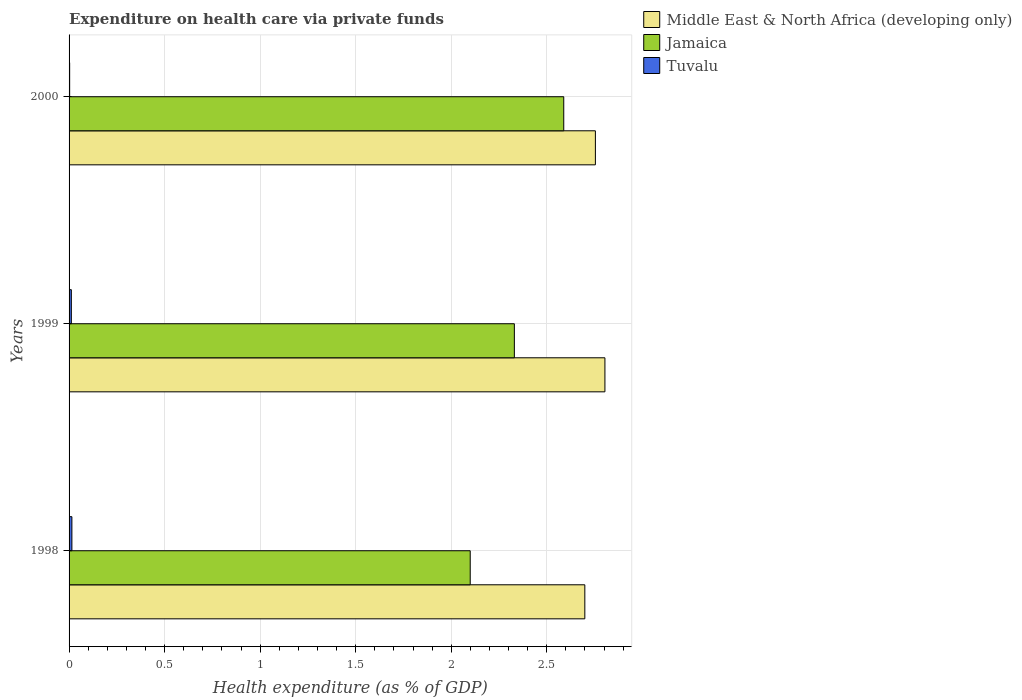Are the number of bars on each tick of the Y-axis equal?
Keep it short and to the point. Yes. How many bars are there on the 2nd tick from the top?
Ensure brevity in your answer.  3. How many bars are there on the 1st tick from the bottom?
Provide a succinct answer. 3. What is the label of the 1st group of bars from the top?
Offer a very short reply. 2000. What is the expenditure made on health care in Tuvalu in 1999?
Give a very brief answer. 0.01. Across all years, what is the maximum expenditure made on health care in Tuvalu?
Provide a succinct answer. 0.01. Across all years, what is the minimum expenditure made on health care in Jamaica?
Provide a short and direct response. 2.1. In which year was the expenditure made on health care in Jamaica minimum?
Ensure brevity in your answer.  1998. What is the total expenditure made on health care in Middle East & North Africa (developing only) in the graph?
Your answer should be compact. 8.26. What is the difference between the expenditure made on health care in Tuvalu in 1998 and that in 2000?
Provide a short and direct response. 0.01. What is the difference between the expenditure made on health care in Middle East & North Africa (developing only) in 2000 and the expenditure made on health care in Jamaica in 1998?
Your response must be concise. 0.66. What is the average expenditure made on health care in Tuvalu per year?
Make the answer very short. 0.01. In the year 1998, what is the difference between the expenditure made on health care in Tuvalu and expenditure made on health care in Jamaica?
Keep it short and to the point. -2.08. What is the ratio of the expenditure made on health care in Middle East & North Africa (developing only) in 1999 to that in 2000?
Provide a short and direct response. 1.02. What is the difference between the highest and the second highest expenditure made on health care in Middle East & North Africa (developing only)?
Your answer should be compact. 0.05. What is the difference between the highest and the lowest expenditure made on health care in Middle East & North Africa (developing only)?
Provide a succinct answer. 0.11. What does the 1st bar from the top in 1999 represents?
Give a very brief answer. Tuvalu. What does the 3rd bar from the bottom in 1999 represents?
Keep it short and to the point. Tuvalu. Is it the case that in every year, the sum of the expenditure made on health care in Tuvalu and expenditure made on health care in Jamaica is greater than the expenditure made on health care in Middle East & North Africa (developing only)?
Make the answer very short. No. How many years are there in the graph?
Provide a succinct answer. 3. What is the difference between two consecutive major ticks on the X-axis?
Provide a short and direct response. 0.5. Are the values on the major ticks of X-axis written in scientific E-notation?
Offer a terse response. No. What is the title of the graph?
Give a very brief answer. Expenditure on health care via private funds. Does "Mauritania" appear as one of the legend labels in the graph?
Make the answer very short. No. What is the label or title of the X-axis?
Give a very brief answer. Health expenditure (as % of GDP). What is the Health expenditure (as % of GDP) in Middle East & North Africa (developing only) in 1998?
Make the answer very short. 2.7. What is the Health expenditure (as % of GDP) of Jamaica in 1998?
Provide a succinct answer. 2.1. What is the Health expenditure (as % of GDP) of Tuvalu in 1998?
Offer a very short reply. 0.01. What is the Health expenditure (as % of GDP) of Middle East & North Africa (developing only) in 1999?
Your answer should be compact. 2.8. What is the Health expenditure (as % of GDP) in Jamaica in 1999?
Provide a short and direct response. 2.33. What is the Health expenditure (as % of GDP) of Tuvalu in 1999?
Your response must be concise. 0.01. What is the Health expenditure (as % of GDP) of Middle East & North Africa (developing only) in 2000?
Your response must be concise. 2.75. What is the Health expenditure (as % of GDP) of Jamaica in 2000?
Make the answer very short. 2.59. What is the Health expenditure (as % of GDP) in Tuvalu in 2000?
Your answer should be compact. 0. Across all years, what is the maximum Health expenditure (as % of GDP) of Middle East & North Africa (developing only)?
Provide a succinct answer. 2.8. Across all years, what is the maximum Health expenditure (as % of GDP) of Jamaica?
Offer a terse response. 2.59. Across all years, what is the maximum Health expenditure (as % of GDP) in Tuvalu?
Make the answer very short. 0.01. Across all years, what is the minimum Health expenditure (as % of GDP) of Middle East & North Africa (developing only)?
Offer a terse response. 2.7. Across all years, what is the minimum Health expenditure (as % of GDP) of Jamaica?
Offer a very short reply. 2.1. Across all years, what is the minimum Health expenditure (as % of GDP) in Tuvalu?
Provide a short and direct response. 0. What is the total Health expenditure (as % of GDP) of Middle East & North Africa (developing only) in the graph?
Give a very brief answer. 8.26. What is the total Health expenditure (as % of GDP) of Jamaica in the graph?
Your answer should be compact. 7.02. What is the total Health expenditure (as % of GDP) in Tuvalu in the graph?
Give a very brief answer. 0.03. What is the difference between the Health expenditure (as % of GDP) in Middle East & North Africa (developing only) in 1998 and that in 1999?
Offer a terse response. -0.11. What is the difference between the Health expenditure (as % of GDP) of Jamaica in 1998 and that in 1999?
Offer a very short reply. -0.23. What is the difference between the Health expenditure (as % of GDP) of Tuvalu in 1998 and that in 1999?
Ensure brevity in your answer.  0. What is the difference between the Health expenditure (as % of GDP) of Middle East & North Africa (developing only) in 1998 and that in 2000?
Provide a short and direct response. -0.06. What is the difference between the Health expenditure (as % of GDP) in Jamaica in 1998 and that in 2000?
Give a very brief answer. -0.49. What is the difference between the Health expenditure (as % of GDP) in Tuvalu in 1998 and that in 2000?
Your answer should be compact. 0.01. What is the difference between the Health expenditure (as % of GDP) of Middle East & North Africa (developing only) in 1999 and that in 2000?
Your answer should be very brief. 0.05. What is the difference between the Health expenditure (as % of GDP) in Jamaica in 1999 and that in 2000?
Your answer should be very brief. -0.26. What is the difference between the Health expenditure (as % of GDP) of Tuvalu in 1999 and that in 2000?
Make the answer very short. 0.01. What is the difference between the Health expenditure (as % of GDP) in Middle East & North Africa (developing only) in 1998 and the Health expenditure (as % of GDP) in Jamaica in 1999?
Your response must be concise. 0.37. What is the difference between the Health expenditure (as % of GDP) of Middle East & North Africa (developing only) in 1998 and the Health expenditure (as % of GDP) of Tuvalu in 1999?
Offer a very short reply. 2.69. What is the difference between the Health expenditure (as % of GDP) of Jamaica in 1998 and the Health expenditure (as % of GDP) of Tuvalu in 1999?
Your answer should be very brief. 2.09. What is the difference between the Health expenditure (as % of GDP) of Middle East & North Africa (developing only) in 1998 and the Health expenditure (as % of GDP) of Jamaica in 2000?
Ensure brevity in your answer.  0.11. What is the difference between the Health expenditure (as % of GDP) in Middle East & North Africa (developing only) in 1998 and the Health expenditure (as % of GDP) in Tuvalu in 2000?
Your answer should be very brief. 2.7. What is the difference between the Health expenditure (as % of GDP) of Jamaica in 1998 and the Health expenditure (as % of GDP) of Tuvalu in 2000?
Your answer should be compact. 2.1. What is the difference between the Health expenditure (as % of GDP) in Middle East & North Africa (developing only) in 1999 and the Health expenditure (as % of GDP) in Jamaica in 2000?
Your answer should be compact. 0.22. What is the difference between the Health expenditure (as % of GDP) in Middle East & North Africa (developing only) in 1999 and the Health expenditure (as % of GDP) in Tuvalu in 2000?
Offer a very short reply. 2.8. What is the difference between the Health expenditure (as % of GDP) in Jamaica in 1999 and the Health expenditure (as % of GDP) in Tuvalu in 2000?
Provide a succinct answer. 2.33. What is the average Health expenditure (as % of GDP) of Middle East & North Africa (developing only) per year?
Keep it short and to the point. 2.75. What is the average Health expenditure (as % of GDP) in Jamaica per year?
Your response must be concise. 2.34. What is the average Health expenditure (as % of GDP) in Tuvalu per year?
Your answer should be compact. 0.01. In the year 1998, what is the difference between the Health expenditure (as % of GDP) in Middle East & North Africa (developing only) and Health expenditure (as % of GDP) in Jamaica?
Provide a succinct answer. 0.6. In the year 1998, what is the difference between the Health expenditure (as % of GDP) in Middle East & North Africa (developing only) and Health expenditure (as % of GDP) in Tuvalu?
Your answer should be compact. 2.68. In the year 1998, what is the difference between the Health expenditure (as % of GDP) in Jamaica and Health expenditure (as % of GDP) in Tuvalu?
Make the answer very short. 2.08. In the year 1999, what is the difference between the Health expenditure (as % of GDP) of Middle East & North Africa (developing only) and Health expenditure (as % of GDP) of Jamaica?
Offer a terse response. 0.47. In the year 1999, what is the difference between the Health expenditure (as % of GDP) in Middle East & North Africa (developing only) and Health expenditure (as % of GDP) in Tuvalu?
Keep it short and to the point. 2.79. In the year 1999, what is the difference between the Health expenditure (as % of GDP) of Jamaica and Health expenditure (as % of GDP) of Tuvalu?
Keep it short and to the point. 2.32. In the year 2000, what is the difference between the Health expenditure (as % of GDP) of Middle East & North Africa (developing only) and Health expenditure (as % of GDP) of Jamaica?
Offer a terse response. 0.17. In the year 2000, what is the difference between the Health expenditure (as % of GDP) in Middle East & North Africa (developing only) and Health expenditure (as % of GDP) in Tuvalu?
Make the answer very short. 2.75. In the year 2000, what is the difference between the Health expenditure (as % of GDP) of Jamaica and Health expenditure (as % of GDP) of Tuvalu?
Provide a short and direct response. 2.59. What is the ratio of the Health expenditure (as % of GDP) of Middle East & North Africa (developing only) in 1998 to that in 1999?
Your answer should be very brief. 0.96. What is the ratio of the Health expenditure (as % of GDP) in Jamaica in 1998 to that in 1999?
Give a very brief answer. 0.9. What is the ratio of the Health expenditure (as % of GDP) of Tuvalu in 1998 to that in 1999?
Provide a succinct answer. 1.24. What is the ratio of the Health expenditure (as % of GDP) in Middle East & North Africa (developing only) in 1998 to that in 2000?
Offer a terse response. 0.98. What is the ratio of the Health expenditure (as % of GDP) of Jamaica in 1998 to that in 2000?
Give a very brief answer. 0.81. What is the ratio of the Health expenditure (as % of GDP) in Tuvalu in 1998 to that in 2000?
Your response must be concise. 4.85. What is the ratio of the Health expenditure (as % of GDP) in Middle East & North Africa (developing only) in 1999 to that in 2000?
Your answer should be compact. 1.02. What is the ratio of the Health expenditure (as % of GDP) in Jamaica in 1999 to that in 2000?
Provide a succinct answer. 0.9. What is the ratio of the Health expenditure (as % of GDP) of Tuvalu in 1999 to that in 2000?
Provide a succinct answer. 3.91. What is the difference between the highest and the second highest Health expenditure (as % of GDP) of Middle East & North Africa (developing only)?
Give a very brief answer. 0.05. What is the difference between the highest and the second highest Health expenditure (as % of GDP) of Jamaica?
Offer a very short reply. 0.26. What is the difference between the highest and the second highest Health expenditure (as % of GDP) of Tuvalu?
Your response must be concise. 0. What is the difference between the highest and the lowest Health expenditure (as % of GDP) in Middle East & North Africa (developing only)?
Offer a terse response. 0.11. What is the difference between the highest and the lowest Health expenditure (as % of GDP) of Jamaica?
Keep it short and to the point. 0.49. What is the difference between the highest and the lowest Health expenditure (as % of GDP) in Tuvalu?
Provide a short and direct response. 0.01. 